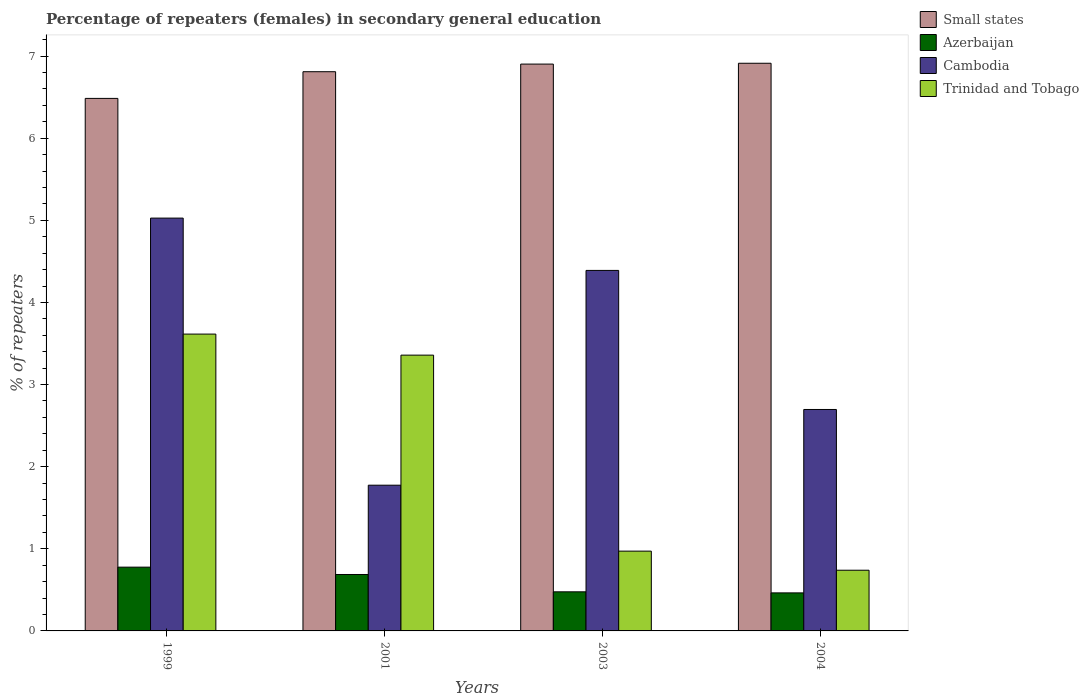Are the number of bars on each tick of the X-axis equal?
Ensure brevity in your answer.  Yes. In how many cases, is the number of bars for a given year not equal to the number of legend labels?
Offer a terse response. 0. What is the percentage of female repeaters in Azerbaijan in 2001?
Your response must be concise. 0.69. Across all years, what is the maximum percentage of female repeaters in Trinidad and Tobago?
Ensure brevity in your answer.  3.61. Across all years, what is the minimum percentage of female repeaters in Cambodia?
Your answer should be compact. 1.77. In which year was the percentage of female repeaters in Cambodia maximum?
Make the answer very short. 1999. What is the total percentage of female repeaters in Azerbaijan in the graph?
Make the answer very short. 2.4. What is the difference between the percentage of female repeaters in Trinidad and Tobago in 1999 and that in 2001?
Your response must be concise. 0.26. What is the difference between the percentage of female repeaters in Azerbaijan in 2003 and the percentage of female repeaters in Trinidad and Tobago in 2004?
Make the answer very short. -0.26. What is the average percentage of female repeaters in Azerbaijan per year?
Make the answer very short. 0.6. In the year 2004, what is the difference between the percentage of female repeaters in Cambodia and percentage of female repeaters in Small states?
Your answer should be compact. -4.22. In how many years, is the percentage of female repeaters in Azerbaijan greater than 4 %?
Your answer should be very brief. 0. What is the ratio of the percentage of female repeaters in Cambodia in 2001 to that in 2004?
Your response must be concise. 0.66. Is the percentage of female repeaters in Cambodia in 1999 less than that in 2004?
Your response must be concise. No. Is the difference between the percentage of female repeaters in Cambodia in 1999 and 2004 greater than the difference between the percentage of female repeaters in Small states in 1999 and 2004?
Offer a very short reply. Yes. What is the difference between the highest and the second highest percentage of female repeaters in Azerbaijan?
Keep it short and to the point. 0.09. What is the difference between the highest and the lowest percentage of female repeaters in Azerbaijan?
Offer a terse response. 0.31. Is it the case that in every year, the sum of the percentage of female repeaters in Trinidad and Tobago and percentage of female repeaters in Azerbaijan is greater than the sum of percentage of female repeaters in Small states and percentage of female repeaters in Cambodia?
Keep it short and to the point. No. What does the 1st bar from the left in 2004 represents?
Keep it short and to the point. Small states. What does the 1st bar from the right in 2001 represents?
Provide a short and direct response. Trinidad and Tobago. How many years are there in the graph?
Give a very brief answer. 4. Does the graph contain any zero values?
Give a very brief answer. No. How are the legend labels stacked?
Ensure brevity in your answer.  Vertical. What is the title of the graph?
Keep it short and to the point. Percentage of repeaters (females) in secondary general education. Does "Brazil" appear as one of the legend labels in the graph?
Provide a short and direct response. No. What is the label or title of the Y-axis?
Ensure brevity in your answer.  % of repeaters. What is the % of repeaters in Small states in 1999?
Your answer should be very brief. 6.49. What is the % of repeaters of Azerbaijan in 1999?
Give a very brief answer. 0.78. What is the % of repeaters in Cambodia in 1999?
Your answer should be compact. 5.03. What is the % of repeaters of Trinidad and Tobago in 1999?
Your response must be concise. 3.61. What is the % of repeaters in Small states in 2001?
Your response must be concise. 6.81. What is the % of repeaters in Azerbaijan in 2001?
Your answer should be very brief. 0.69. What is the % of repeaters in Cambodia in 2001?
Your answer should be compact. 1.77. What is the % of repeaters of Trinidad and Tobago in 2001?
Provide a short and direct response. 3.36. What is the % of repeaters of Small states in 2003?
Ensure brevity in your answer.  6.9. What is the % of repeaters in Azerbaijan in 2003?
Make the answer very short. 0.48. What is the % of repeaters in Cambodia in 2003?
Make the answer very short. 4.39. What is the % of repeaters in Trinidad and Tobago in 2003?
Provide a succinct answer. 0.97. What is the % of repeaters in Small states in 2004?
Offer a very short reply. 6.91. What is the % of repeaters in Azerbaijan in 2004?
Give a very brief answer. 0.46. What is the % of repeaters of Cambodia in 2004?
Your answer should be compact. 2.7. What is the % of repeaters in Trinidad and Tobago in 2004?
Your answer should be compact. 0.74. Across all years, what is the maximum % of repeaters of Small states?
Keep it short and to the point. 6.91. Across all years, what is the maximum % of repeaters in Azerbaijan?
Keep it short and to the point. 0.78. Across all years, what is the maximum % of repeaters in Cambodia?
Ensure brevity in your answer.  5.03. Across all years, what is the maximum % of repeaters in Trinidad and Tobago?
Ensure brevity in your answer.  3.61. Across all years, what is the minimum % of repeaters in Small states?
Offer a terse response. 6.49. Across all years, what is the minimum % of repeaters in Azerbaijan?
Your response must be concise. 0.46. Across all years, what is the minimum % of repeaters in Cambodia?
Offer a very short reply. 1.77. Across all years, what is the minimum % of repeaters of Trinidad and Tobago?
Offer a terse response. 0.74. What is the total % of repeaters of Small states in the graph?
Ensure brevity in your answer.  27.11. What is the total % of repeaters in Azerbaijan in the graph?
Your answer should be compact. 2.4. What is the total % of repeaters of Cambodia in the graph?
Offer a terse response. 13.89. What is the total % of repeaters of Trinidad and Tobago in the graph?
Your answer should be very brief. 8.68. What is the difference between the % of repeaters in Small states in 1999 and that in 2001?
Your answer should be very brief. -0.32. What is the difference between the % of repeaters of Azerbaijan in 1999 and that in 2001?
Ensure brevity in your answer.  0.09. What is the difference between the % of repeaters in Cambodia in 1999 and that in 2001?
Offer a very short reply. 3.25. What is the difference between the % of repeaters of Trinidad and Tobago in 1999 and that in 2001?
Give a very brief answer. 0.26. What is the difference between the % of repeaters of Small states in 1999 and that in 2003?
Provide a short and direct response. -0.42. What is the difference between the % of repeaters in Azerbaijan in 1999 and that in 2003?
Your answer should be very brief. 0.3. What is the difference between the % of repeaters of Cambodia in 1999 and that in 2003?
Make the answer very short. 0.64. What is the difference between the % of repeaters of Trinidad and Tobago in 1999 and that in 2003?
Provide a succinct answer. 2.64. What is the difference between the % of repeaters of Small states in 1999 and that in 2004?
Make the answer very short. -0.43. What is the difference between the % of repeaters of Azerbaijan in 1999 and that in 2004?
Keep it short and to the point. 0.31. What is the difference between the % of repeaters in Cambodia in 1999 and that in 2004?
Give a very brief answer. 2.33. What is the difference between the % of repeaters of Trinidad and Tobago in 1999 and that in 2004?
Ensure brevity in your answer.  2.88. What is the difference between the % of repeaters of Small states in 2001 and that in 2003?
Ensure brevity in your answer.  -0.09. What is the difference between the % of repeaters of Azerbaijan in 2001 and that in 2003?
Provide a succinct answer. 0.21. What is the difference between the % of repeaters in Cambodia in 2001 and that in 2003?
Give a very brief answer. -2.62. What is the difference between the % of repeaters in Trinidad and Tobago in 2001 and that in 2003?
Your answer should be very brief. 2.39. What is the difference between the % of repeaters of Small states in 2001 and that in 2004?
Provide a succinct answer. -0.1. What is the difference between the % of repeaters in Azerbaijan in 2001 and that in 2004?
Keep it short and to the point. 0.22. What is the difference between the % of repeaters of Cambodia in 2001 and that in 2004?
Your answer should be very brief. -0.92. What is the difference between the % of repeaters of Trinidad and Tobago in 2001 and that in 2004?
Your answer should be very brief. 2.62. What is the difference between the % of repeaters in Small states in 2003 and that in 2004?
Your answer should be compact. -0.01. What is the difference between the % of repeaters of Azerbaijan in 2003 and that in 2004?
Ensure brevity in your answer.  0.01. What is the difference between the % of repeaters of Cambodia in 2003 and that in 2004?
Make the answer very short. 1.69. What is the difference between the % of repeaters of Trinidad and Tobago in 2003 and that in 2004?
Offer a very short reply. 0.23. What is the difference between the % of repeaters in Small states in 1999 and the % of repeaters in Azerbaijan in 2001?
Provide a succinct answer. 5.8. What is the difference between the % of repeaters in Small states in 1999 and the % of repeaters in Cambodia in 2001?
Ensure brevity in your answer.  4.71. What is the difference between the % of repeaters in Small states in 1999 and the % of repeaters in Trinidad and Tobago in 2001?
Provide a short and direct response. 3.13. What is the difference between the % of repeaters of Azerbaijan in 1999 and the % of repeaters of Cambodia in 2001?
Give a very brief answer. -1. What is the difference between the % of repeaters of Azerbaijan in 1999 and the % of repeaters of Trinidad and Tobago in 2001?
Keep it short and to the point. -2.58. What is the difference between the % of repeaters in Cambodia in 1999 and the % of repeaters in Trinidad and Tobago in 2001?
Provide a short and direct response. 1.67. What is the difference between the % of repeaters of Small states in 1999 and the % of repeaters of Azerbaijan in 2003?
Your answer should be very brief. 6.01. What is the difference between the % of repeaters of Small states in 1999 and the % of repeaters of Cambodia in 2003?
Ensure brevity in your answer.  2.09. What is the difference between the % of repeaters in Small states in 1999 and the % of repeaters in Trinidad and Tobago in 2003?
Your answer should be very brief. 5.51. What is the difference between the % of repeaters of Azerbaijan in 1999 and the % of repeaters of Cambodia in 2003?
Offer a very short reply. -3.61. What is the difference between the % of repeaters in Azerbaijan in 1999 and the % of repeaters in Trinidad and Tobago in 2003?
Make the answer very short. -0.2. What is the difference between the % of repeaters of Cambodia in 1999 and the % of repeaters of Trinidad and Tobago in 2003?
Provide a short and direct response. 4.06. What is the difference between the % of repeaters in Small states in 1999 and the % of repeaters in Azerbaijan in 2004?
Offer a terse response. 6.02. What is the difference between the % of repeaters of Small states in 1999 and the % of repeaters of Cambodia in 2004?
Your response must be concise. 3.79. What is the difference between the % of repeaters in Small states in 1999 and the % of repeaters in Trinidad and Tobago in 2004?
Give a very brief answer. 5.75. What is the difference between the % of repeaters of Azerbaijan in 1999 and the % of repeaters of Cambodia in 2004?
Provide a succinct answer. -1.92. What is the difference between the % of repeaters in Azerbaijan in 1999 and the % of repeaters in Trinidad and Tobago in 2004?
Offer a terse response. 0.04. What is the difference between the % of repeaters of Cambodia in 1999 and the % of repeaters of Trinidad and Tobago in 2004?
Your response must be concise. 4.29. What is the difference between the % of repeaters in Small states in 2001 and the % of repeaters in Azerbaijan in 2003?
Your answer should be compact. 6.33. What is the difference between the % of repeaters in Small states in 2001 and the % of repeaters in Cambodia in 2003?
Keep it short and to the point. 2.42. What is the difference between the % of repeaters of Small states in 2001 and the % of repeaters of Trinidad and Tobago in 2003?
Provide a succinct answer. 5.84. What is the difference between the % of repeaters of Azerbaijan in 2001 and the % of repeaters of Cambodia in 2003?
Keep it short and to the point. -3.7. What is the difference between the % of repeaters of Azerbaijan in 2001 and the % of repeaters of Trinidad and Tobago in 2003?
Your response must be concise. -0.28. What is the difference between the % of repeaters of Cambodia in 2001 and the % of repeaters of Trinidad and Tobago in 2003?
Offer a terse response. 0.8. What is the difference between the % of repeaters in Small states in 2001 and the % of repeaters in Azerbaijan in 2004?
Offer a terse response. 6.35. What is the difference between the % of repeaters in Small states in 2001 and the % of repeaters in Cambodia in 2004?
Your response must be concise. 4.11. What is the difference between the % of repeaters of Small states in 2001 and the % of repeaters of Trinidad and Tobago in 2004?
Your answer should be very brief. 6.07. What is the difference between the % of repeaters of Azerbaijan in 2001 and the % of repeaters of Cambodia in 2004?
Make the answer very short. -2.01. What is the difference between the % of repeaters of Azerbaijan in 2001 and the % of repeaters of Trinidad and Tobago in 2004?
Ensure brevity in your answer.  -0.05. What is the difference between the % of repeaters of Cambodia in 2001 and the % of repeaters of Trinidad and Tobago in 2004?
Make the answer very short. 1.04. What is the difference between the % of repeaters in Small states in 2003 and the % of repeaters in Azerbaijan in 2004?
Give a very brief answer. 6.44. What is the difference between the % of repeaters in Small states in 2003 and the % of repeaters in Cambodia in 2004?
Your response must be concise. 4.21. What is the difference between the % of repeaters in Small states in 2003 and the % of repeaters in Trinidad and Tobago in 2004?
Provide a succinct answer. 6.16. What is the difference between the % of repeaters in Azerbaijan in 2003 and the % of repeaters in Cambodia in 2004?
Offer a terse response. -2.22. What is the difference between the % of repeaters of Azerbaijan in 2003 and the % of repeaters of Trinidad and Tobago in 2004?
Your answer should be compact. -0.26. What is the difference between the % of repeaters of Cambodia in 2003 and the % of repeaters of Trinidad and Tobago in 2004?
Your response must be concise. 3.65. What is the average % of repeaters of Small states per year?
Your answer should be compact. 6.78. What is the average % of repeaters in Azerbaijan per year?
Offer a terse response. 0.6. What is the average % of repeaters of Cambodia per year?
Provide a succinct answer. 3.47. What is the average % of repeaters of Trinidad and Tobago per year?
Provide a short and direct response. 2.17. In the year 1999, what is the difference between the % of repeaters in Small states and % of repeaters in Azerbaijan?
Give a very brief answer. 5.71. In the year 1999, what is the difference between the % of repeaters of Small states and % of repeaters of Cambodia?
Provide a succinct answer. 1.46. In the year 1999, what is the difference between the % of repeaters in Small states and % of repeaters in Trinidad and Tobago?
Offer a terse response. 2.87. In the year 1999, what is the difference between the % of repeaters in Azerbaijan and % of repeaters in Cambodia?
Your response must be concise. -4.25. In the year 1999, what is the difference between the % of repeaters in Azerbaijan and % of repeaters in Trinidad and Tobago?
Give a very brief answer. -2.84. In the year 1999, what is the difference between the % of repeaters of Cambodia and % of repeaters of Trinidad and Tobago?
Offer a very short reply. 1.41. In the year 2001, what is the difference between the % of repeaters in Small states and % of repeaters in Azerbaijan?
Provide a succinct answer. 6.12. In the year 2001, what is the difference between the % of repeaters of Small states and % of repeaters of Cambodia?
Your response must be concise. 5.04. In the year 2001, what is the difference between the % of repeaters in Small states and % of repeaters in Trinidad and Tobago?
Keep it short and to the point. 3.45. In the year 2001, what is the difference between the % of repeaters of Azerbaijan and % of repeaters of Cambodia?
Your answer should be compact. -1.09. In the year 2001, what is the difference between the % of repeaters in Azerbaijan and % of repeaters in Trinidad and Tobago?
Your answer should be compact. -2.67. In the year 2001, what is the difference between the % of repeaters of Cambodia and % of repeaters of Trinidad and Tobago?
Keep it short and to the point. -1.58. In the year 2003, what is the difference between the % of repeaters of Small states and % of repeaters of Azerbaijan?
Ensure brevity in your answer.  6.43. In the year 2003, what is the difference between the % of repeaters of Small states and % of repeaters of Cambodia?
Offer a terse response. 2.51. In the year 2003, what is the difference between the % of repeaters of Small states and % of repeaters of Trinidad and Tobago?
Ensure brevity in your answer.  5.93. In the year 2003, what is the difference between the % of repeaters of Azerbaijan and % of repeaters of Cambodia?
Offer a terse response. -3.91. In the year 2003, what is the difference between the % of repeaters of Azerbaijan and % of repeaters of Trinidad and Tobago?
Ensure brevity in your answer.  -0.5. In the year 2003, what is the difference between the % of repeaters of Cambodia and % of repeaters of Trinidad and Tobago?
Make the answer very short. 3.42. In the year 2004, what is the difference between the % of repeaters in Small states and % of repeaters in Azerbaijan?
Your answer should be very brief. 6.45. In the year 2004, what is the difference between the % of repeaters in Small states and % of repeaters in Cambodia?
Your response must be concise. 4.22. In the year 2004, what is the difference between the % of repeaters in Small states and % of repeaters in Trinidad and Tobago?
Offer a very short reply. 6.17. In the year 2004, what is the difference between the % of repeaters of Azerbaijan and % of repeaters of Cambodia?
Your answer should be very brief. -2.23. In the year 2004, what is the difference between the % of repeaters in Azerbaijan and % of repeaters in Trinidad and Tobago?
Give a very brief answer. -0.28. In the year 2004, what is the difference between the % of repeaters in Cambodia and % of repeaters in Trinidad and Tobago?
Offer a terse response. 1.96. What is the ratio of the % of repeaters of Small states in 1999 to that in 2001?
Offer a very short reply. 0.95. What is the ratio of the % of repeaters in Azerbaijan in 1999 to that in 2001?
Your answer should be very brief. 1.13. What is the ratio of the % of repeaters of Cambodia in 1999 to that in 2001?
Your response must be concise. 2.83. What is the ratio of the % of repeaters in Trinidad and Tobago in 1999 to that in 2001?
Provide a short and direct response. 1.08. What is the ratio of the % of repeaters in Small states in 1999 to that in 2003?
Ensure brevity in your answer.  0.94. What is the ratio of the % of repeaters of Azerbaijan in 1999 to that in 2003?
Make the answer very short. 1.63. What is the ratio of the % of repeaters in Cambodia in 1999 to that in 2003?
Your answer should be compact. 1.15. What is the ratio of the % of repeaters in Trinidad and Tobago in 1999 to that in 2003?
Ensure brevity in your answer.  3.72. What is the ratio of the % of repeaters of Small states in 1999 to that in 2004?
Keep it short and to the point. 0.94. What is the ratio of the % of repeaters in Azerbaijan in 1999 to that in 2004?
Provide a short and direct response. 1.68. What is the ratio of the % of repeaters of Cambodia in 1999 to that in 2004?
Offer a very short reply. 1.86. What is the ratio of the % of repeaters of Trinidad and Tobago in 1999 to that in 2004?
Offer a terse response. 4.89. What is the ratio of the % of repeaters in Small states in 2001 to that in 2003?
Provide a short and direct response. 0.99. What is the ratio of the % of repeaters in Azerbaijan in 2001 to that in 2003?
Keep it short and to the point. 1.44. What is the ratio of the % of repeaters of Cambodia in 2001 to that in 2003?
Your answer should be very brief. 0.4. What is the ratio of the % of repeaters in Trinidad and Tobago in 2001 to that in 2003?
Ensure brevity in your answer.  3.46. What is the ratio of the % of repeaters in Small states in 2001 to that in 2004?
Keep it short and to the point. 0.99. What is the ratio of the % of repeaters of Azerbaijan in 2001 to that in 2004?
Your answer should be compact. 1.48. What is the ratio of the % of repeaters in Cambodia in 2001 to that in 2004?
Your answer should be compact. 0.66. What is the ratio of the % of repeaters of Trinidad and Tobago in 2001 to that in 2004?
Keep it short and to the point. 4.54. What is the ratio of the % of repeaters in Azerbaijan in 2003 to that in 2004?
Your answer should be compact. 1.03. What is the ratio of the % of repeaters in Cambodia in 2003 to that in 2004?
Make the answer very short. 1.63. What is the ratio of the % of repeaters in Trinidad and Tobago in 2003 to that in 2004?
Your answer should be very brief. 1.31. What is the difference between the highest and the second highest % of repeaters of Small states?
Provide a succinct answer. 0.01. What is the difference between the highest and the second highest % of repeaters in Azerbaijan?
Your response must be concise. 0.09. What is the difference between the highest and the second highest % of repeaters in Cambodia?
Your answer should be compact. 0.64. What is the difference between the highest and the second highest % of repeaters in Trinidad and Tobago?
Make the answer very short. 0.26. What is the difference between the highest and the lowest % of repeaters in Small states?
Your response must be concise. 0.43. What is the difference between the highest and the lowest % of repeaters of Azerbaijan?
Your response must be concise. 0.31. What is the difference between the highest and the lowest % of repeaters in Cambodia?
Make the answer very short. 3.25. What is the difference between the highest and the lowest % of repeaters in Trinidad and Tobago?
Your answer should be very brief. 2.88. 